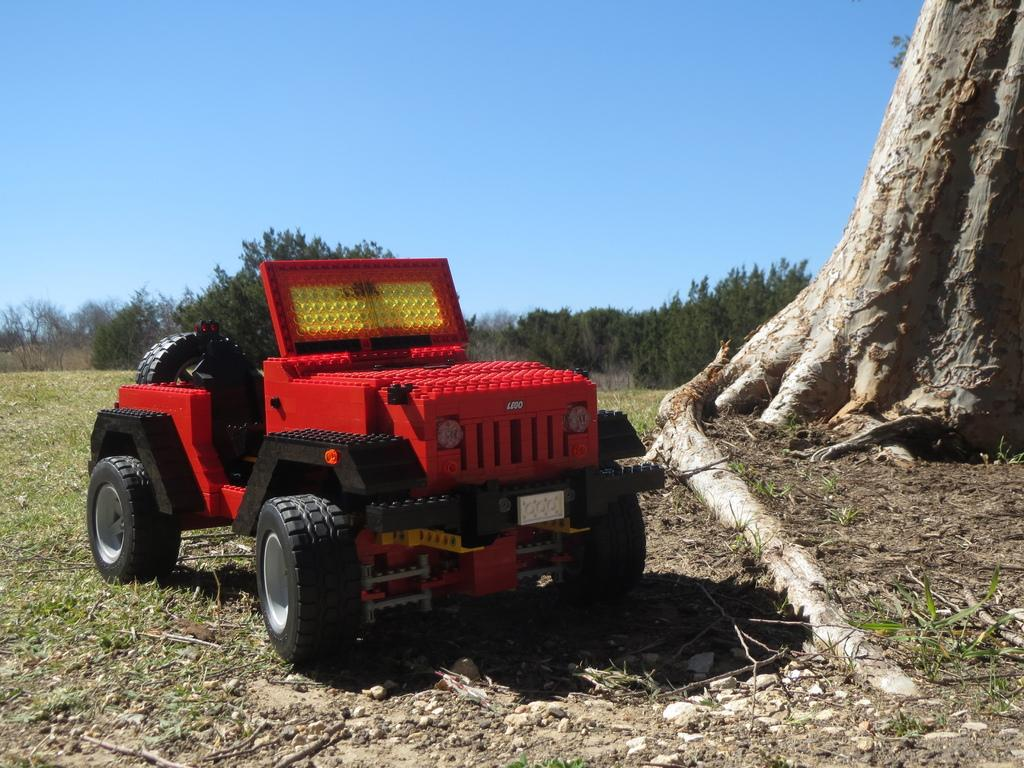What type of toy is present in the image? There is a toy jeep in the image. Where is the toy jeep located? The toy jeep is on the ground. What is the ground made of in the image? The ground has grass. What can be seen in the background of the image? There are trees visible in the image, and the sky is clear and visible. What verse is being recited by the toy jeep in the image? There is no verse being recited by the toy jeep in the image, as it is an inanimate object and cannot speak or recite verses. 